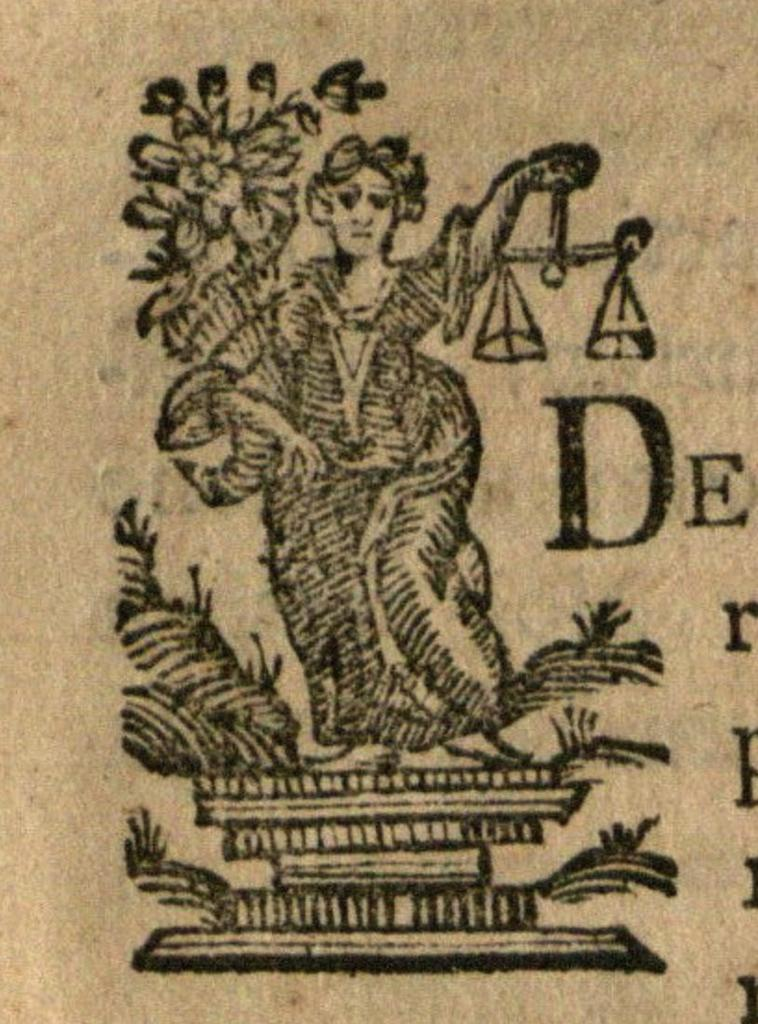Provide a one-sentence caption for the provided image. The letter D appears to the right of a woman holding scales. 